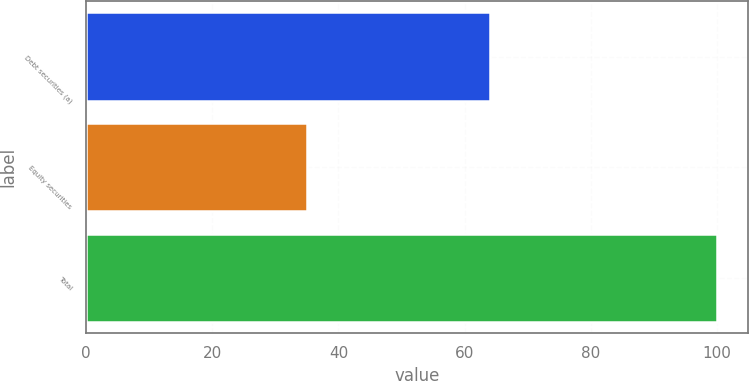<chart> <loc_0><loc_0><loc_500><loc_500><bar_chart><fcel>Debt securities (a)<fcel>Equity securities<fcel>Total<nl><fcel>64<fcel>35<fcel>100<nl></chart> 